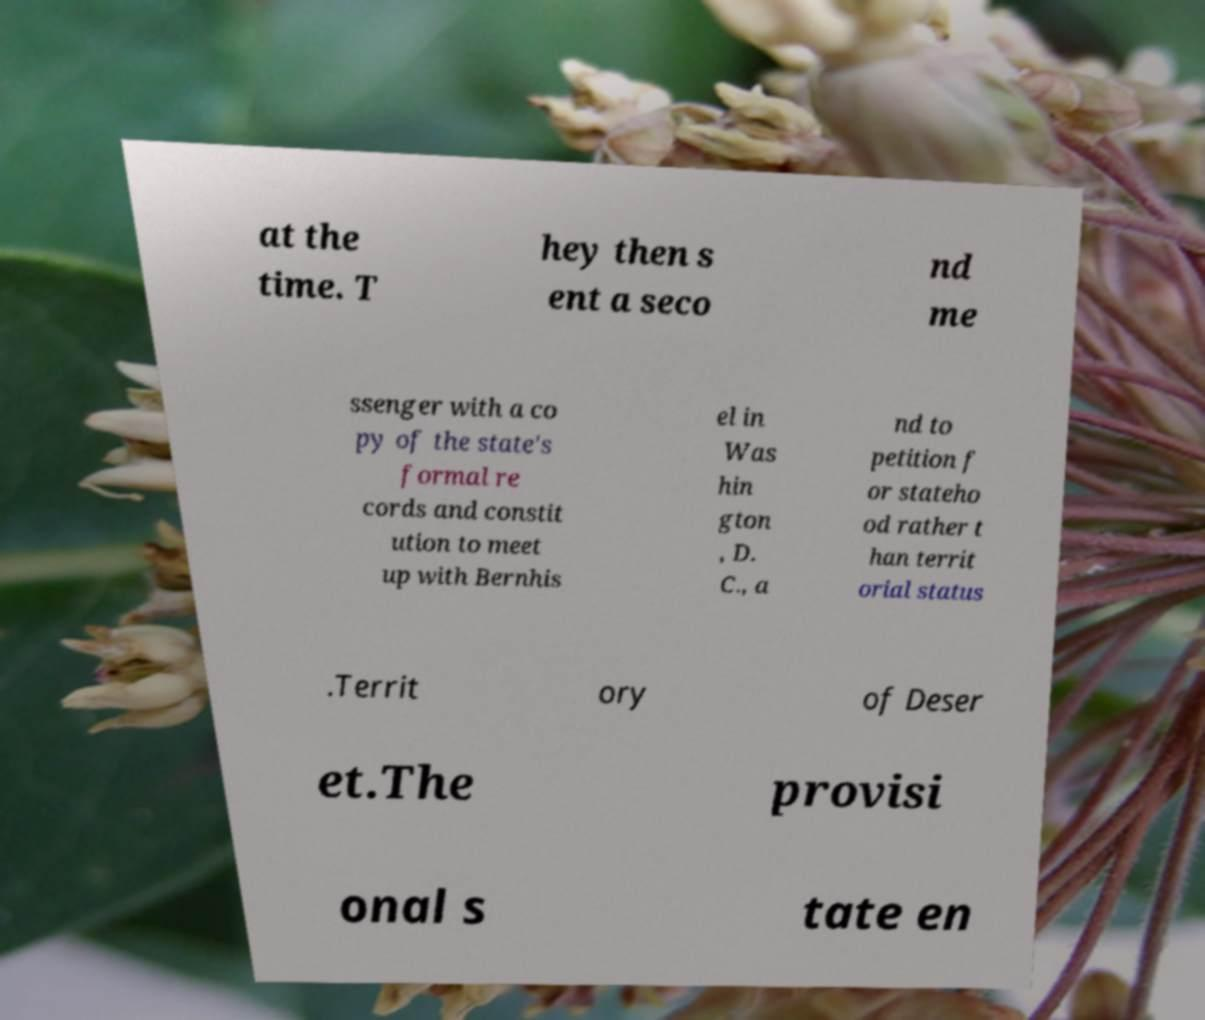Please identify and transcribe the text found in this image. at the time. T hey then s ent a seco nd me ssenger with a co py of the state's formal re cords and constit ution to meet up with Bernhis el in Was hin gton , D. C., a nd to petition f or stateho od rather t han territ orial status .Territ ory of Deser et.The provisi onal s tate en 